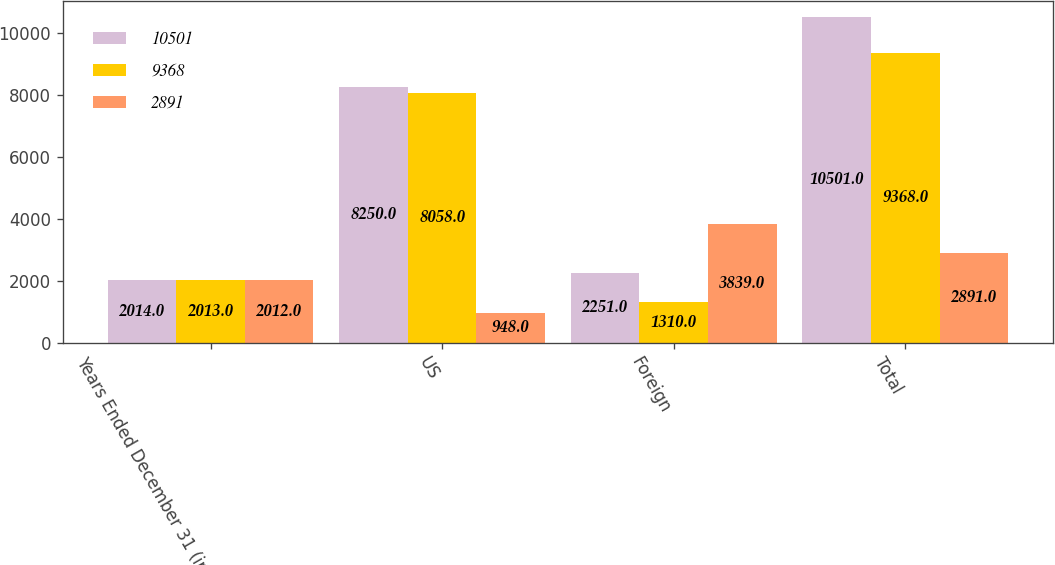Convert chart. <chart><loc_0><loc_0><loc_500><loc_500><stacked_bar_chart><ecel><fcel>Years Ended December 31 (in<fcel>US<fcel>Foreign<fcel>Total<nl><fcel>10501<fcel>2014<fcel>8250<fcel>2251<fcel>10501<nl><fcel>9368<fcel>2013<fcel>8058<fcel>1310<fcel>9368<nl><fcel>2891<fcel>2012<fcel>948<fcel>3839<fcel>2891<nl></chart> 